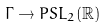<formula> <loc_0><loc_0><loc_500><loc_500>\Gamma \to P S L _ { 2 } ( \mathbb { R } )</formula> 